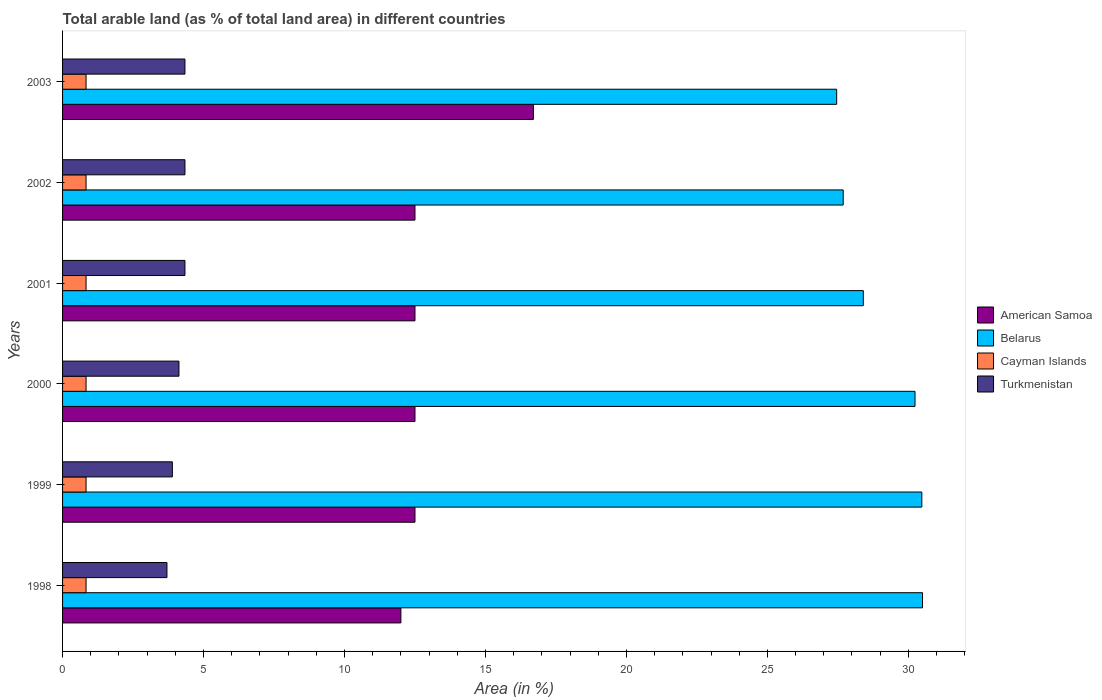How many different coloured bars are there?
Offer a very short reply. 4. How many groups of bars are there?
Provide a succinct answer. 6. Are the number of bars per tick equal to the number of legend labels?
Your answer should be very brief. Yes. How many bars are there on the 5th tick from the top?
Offer a very short reply. 4. How many bars are there on the 1st tick from the bottom?
Ensure brevity in your answer.  4. In how many cases, is the number of bars for a given year not equal to the number of legend labels?
Make the answer very short. 0. What is the percentage of arable land in Cayman Islands in 2003?
Offer a terse response. 0.83. Across all years, what is the maximum percentage of arable land in Cayman Islands?
Provide a succinct answer. 0.83. Across all years, what is the minimum percentage of arable land in Cayman Islands?
Give a very brief answer. 0.83. In which year was the percentage of arable land in Belarus maximum?
Offer a terse response. 1998. In which year was the percentage of arable land in Cayman Islands minimum?
Provide a succinct answer. 1998. What is the total percentage of arable land in Turkmenistan in the graph?
Provide a short and direct response. 24.75. What is the difference between the percentage of arable land in Turkmenistan in 1998 and the percentage of arable land in American Samoa in 2001?
Your answer should be very brief. -8.8. What is the average percentage of arable land in American Samoa per year?
Provide a succinct answer. 13.12. In the year 2001, what is the difference between the percentage of arable land in Turkmenistan and percentage of arable land in Cayman Islands?
Your response must be concise. 3.51. What is the ratio of the percentage of arable land in Cayman Islands in 1998 to that in 1999?
Provide a short and direct response. 1. What is the difference between the highest and the lowest percentage of arable land in Cayman Islands?
Give a very brief answer. 0. In how many years, is the percentage of arable land in Turkmenistan greater than the average percentage of arable land in Turkmenistan taken over all years?
Your response must be concise. 4. Is the sum of the percentage of arable land in Cayman Islands in 2000 and 2001 greater than the maximum percentage of arable land in American Samoa across all years?
Your response must be concise. No. What does the 4th bar from the top in 2003 represents?
Your response must be concise. American Samoa. What does the 1st bar from the bottom in 1998 represents?
Your answer should be compact. American Samoa. Is it the case that in every year, the sum of the percentage of arable land in American Samoa and percentage of arable land in Cayman Islands is greater than the percentage of arable land in Belarus?
Give a very brief answer. No. How many bars are there?
Offer a very short reply. 24. Are all the bars in the graph horizontal?
Provide a short and direct response. Yes. How many years are there in the graph?
Offer a very short reply. 6. Are the values on the major ticks of X-axis written in scientific E-notation?
Offer a terse response. No. Does the graph contain any zero values?
Your response must be concise. No. Where does the legend appear in the graph?
Make the answer very short. Center right. How many legend labels are there?
Give a very brief answer. 4. What is the title of the graph?
Your answer should be compact. Total arable land (as % of total land area) in different countries. What is the label or title of the X-axis?
Your answer should be compact. Area (in %). What is the label or title of the Y-axis?
Provide a succinct answer. Years. What is the Area (in %) in Belarus in 1998?
Keep it short and to the point. 30.5. What is the Area (in %) in Cayman Islands in 1998?
Your answer should be very brief. 0.83. What is the Area (in %) in Turkmenistan in 1998?
Your answer should be very brief. 3.7. What is the Area (in %) in Belarus in 1999?
Your answer should be very brief. 30.48. What is the Area (in %) in Cayman Islands in 1999?
Offer a terse response. 0.83. What is the Area (in %) of Turkmenistan in 1999?
Give a very brief answer. 3.89. What is the Area (in %) of Belarus in 2000?
Give a very brief answer. 30.24. What is the Area (in %) in Cayman Islands in 2000?
Make the answer very short. 0.83. What is the Area (in %) in Turkmenistan in 2000?
Provide a succinct answer. 4.13. What is the Area (in %) in American Samoa in 2001?
Make the answer very short. 12.5. What is the Area (in %) of Belarus in 2001?
Make the answer very short. 28.4. What is the Area (in %) of Cayman Islands in 2001?
Make the answer very short. 0.83. What is the Area (in %) in Turkmenistan in 2001?
Make the answer very short. 4.34. What is the Area (in %) in American Samoa in 2002?
Offer a terse response. 12.5. What is the Area (in %) of Belarus in 2002?
Give a very brief answer. 27.69. What is the Area (in %) in Cayman Islands in 2002?
Ensure brevity in your answer.  0.83. What is the Area (in %) of Turkmenistan in 2002?
Give a very brief answer. 4.34. What is the Area (in %) in Belarus in 2003?
Provide a short and direct response. 27.46. What is the Area (in %) in Cayman Islands in 2003?
Your response must be concise. 0.83. What is the Area (in %) in Turkmenistan in 2003?
Your answer should be very brief. 4.34. Across all years, what is the maximum Area (in %) of American Samoa?
Your response must be concise. 16.7. Across all years, what is the maximum Area (in %) of Belarus?
Provide a succinct answer. 30.5. Across all years, what is the maximum Area (in %) in Cayman Islands?
Your answer should be compact. 0.83. Across all years, what is the maximum Area (in %) in Turkmenistan?
Make the answer very short. 4.34. Across all years, what is the minimum Area (in %) in Belarus?
Your response must be concise. 27.46. Across all years, what is the minimum Area (in %) of Cayman Islands?
Give a very brief answer. 0.83. Across all years, what is the minimum Area (in %) of Turkmenistan?
Offer a very short reply. 3.7. What is the total Area (in %) in American Samoa in the graph?
Ensure brevity in your answer.  78.7. What is the total Area (in %) in Belarus in the graph?
Offer a very short reply. 174.76. What is the total Area (in %) of Turkmenistan in the graph?
Your response must be concise. 24.75. What is the difference between the Area (in %) in American Samoa in 1998 and that in 1999?
Give a very brief answer. -0.5. What is the difference between the Area (in %) of Belarus in 1998 and that in 1999?
Ensure brevity in your answer.  0.02. What is the difference between the Area (in %) in Turkmenistan in 1998 and that in 1999?
Provide a succinct answer. -0.19. What is the difference between the Area (in %) of American Samoa in 1998 and that in 2000?
Provide a short and direct response. -0.5. What is the difference between the Area (in %) in Belarus in 1998 and that in 2000?
Give a very brief answer. 0.27. What is the difference between the Area (in %) of Turkmenistan in 1998 and that in 2000?
Provide a succinct answer. -0.43. What is the difference between the Area (in %) of American Samoa in 1998 and that in 2001?
Ensure brevity in your answer.  -0.5. What is the difference between the Area (in %) in Belarus in 1998 and that in 2001?
Your answer should be compact. 2.1. What is the difference between the Area (in %) of Cayman Islands in 1998 and that in 2001?
Make the answer very short. 0. What is the difference between the Area (in %) in Turkmenistan in 1998 and that in 2001?
Provide a succinct answer. -0.64. What is the difference between the Area (in %) of American Samoa in 1998 and that in 2002?
Offer a very short reply. -0.5. What is the difference between the Area (in %) of Belarus in 1998 and that in 2002?
Your answer should be compact. 2.81. What is the difference between the Area (in %) of Turkmenistan in 1998 and that in 2002?
Provide a succinct answer. -0.64. What is the difference between the Area (in %) of American Samoa in 1998 and that in 2003?
Your response must be concise. -4.7. What is the difference between the Area (in %) in Belarus in 1998 and that in 2003?
Your response must be concise. 3.05. What is the difference between the Area (in %) of Cayman Islands in 1998 and that in 2003?
Your answer should be compact. 0. What is the difference between the Area (in %) of Turkmenistan in 1998 and that in 2003?
Give a very brief answer. -0.64. What is the difference between the Area (in %) of American Samoa in 1999 and that in 2000?
Your answer should be compact. 0. What is the difference between the Area (in %) in Belarus in 1999 and that in 2000?
Give a very brief answer. 0.24. What is the difference between the Area (in %) in Cayman Islands in 1999 and that in 2000?
Offer a very short reply. 0. What is the difference between the Area (in %) of Turkmenistan in 1999 and that in 2000?
Make the answer very short. -0.23. What is the difference between the Area (in %) of American Samoa in 1999 and that in 2001?
Offer a terse response. 0. What is the difference between the Area (in %) in Belarus in 1999 and that in 2001?
Your answer should be compact. 2.08. What is the difference between the Area (in %) in Cayman Islands in 1999 and that in 2001?
Provide a succinct answer. 0. What is the difference between the Area (in %) in Turkmenistan in 1999 and that in 2001?
Offer a terse response. -0.45. What is the difference between the Area (in %) in American Samoa in 1999 and that in 2002?
Your answer should be very brief. 0. What is the difference between the Area (in %) of Belarus in 1999 and that in 2002?
Keep it short and to the point. 2.79. What is the difference between the Area (in %) in Cayman Islands in 1999 and that in 2002?
Ensure brevity in your answer.  0. What is the difference between the Area (in %) of Turkmenistan in 1999 and that in 2002?
Your answer should be compact. -0.45. What is the difference between the Area (in %) of American Samoa in 1999 and that in 2003?
Give a very brief answer. -4.2. What is the difference between the Area (in %) of Belarus in 1999 and that in 2003?
Ensure brevity in your answer.  3.02. What is the difference between the Area (in %) of Turkmenistan in 1999 and that in 2003?
Keep it short and to the point. -0.45. What is the difference between the Area (in %) in Belarus in 2000 and that in 2001?
Your answer should be compact. 1.83. What is the difference between the Area (in %) of Cayman Islands in 2000 and that in 2001?
Keep it short and to the point. 0. What is the difference between the Area (in %) in Turkmenistan in 2000 and that in 2001?
Give a very brief answer. -0.21. What is the difference between the Area (in %) in Belarus in 2000 and that in 2002?
Provide a short and direct response. 2.55. What is the difference between the Area (in %) of Turkmenistan in 2000 and that in 2002?
Provide a short and direct response. -0.21. What is the difference between the Area (in %) of American Samoa in 2000 and that in 2003?
Ensure brevity in your answer.  -4.2. What is the difference between the Area (in %) in Belarus in 2000 and that in 2003?
Your answer should be very brief. 2.78. What is the difference between the Area (in %) of Turkmenistan in 2000 and that in 2003?
Give a very brief answer. -0.21. What is the difference between the Area (in %) in Belarus in 2001 and that in 2002?
Your answer should be very brief. 0.71. What is the difference between the Area (in %) of Cayman Islands in 2001 and that in 2002?
Your answer should be compact. 0. What is the difference between the Area (in %) in Turkmenistan in 2001 and that in 2002?
Give a very brief answer. 0. What is the difference between the Area (in %) in American Samoa in 2001 and that in 2003?
Your response must be concise. -4.2. What is the difference between the Area (in %) in Belarus in 2001 and that in 2003?
Offer a very short reply. 0.95. What is the difference between the Area (in %) in Turkmenistan in 2001 and that in 2003?
Make the answer very short. 0. What is the difference between the Area (in %) in Belarus in 2002 and that in 2003?
Give a very brief answer. 0.23. What is the difference between the Area (in %) of American Samoa in 1998 and the Area (in %) of Belarus in 1999?
Your answer should be compact. -18.48. What is the difference between the Area (in %) in American Samoa in 1998 and the Area (in %) in Cayman Islands in 1999?
Your response must be concise. 11.17. What is the difference between the Area (in %) of American Samoa in 1998 and the Area (in %) of Turkmenistan in 1999?
Keep it short and to the point. 8.11. What is the difference between the Area (in %) of Belarus in 1998 and the Area (in %) of Cayman Islands in 1999?
Offer a very short reply. 29.67. What is the difference between the Area (in %) of Belarus in 1998 and the Area (in %) of Turkmenistan in 1999?
Offer a very short reply. 26.61. What is the difference between the Area (in %) in Cayman Islands in 1998 and the Area (in %) in Turkmenistan in 1999?
Your response must be concise. -3.06. What is the difference between the Area (in %) of American Samoa in 1998 and the Area (in %) of Belarus in 2000?
Your answer should be very brief. -18.24. What is the difference between the Area (in %) in American Samoa in 1998 and the Area (in %) in Cayman Islands in 2000?
Your answer should be very brief. 11.17. What is the difference between the Area (in %) of American Samoa in 1998 and the Area (in %) of Turkmenistan in 2000?
Make the answer very short. 7.87. What is the difference between the Area (in %) of Belarus in 1998 and the Area (in %) of Cayman Islands in 2000?
Make the answer very short. 29.67. What is the difference between the Area (in %) of Belarus in 1998 and the Area (in %) of Turkmenistan in 2000?
Provide a short and direct response. 26.37. What is the difference between the Area (in %) of Cayman Islands in 1998 and the Area (in %) of Turkmenistan in 2000?
Ensure brevity in your answer.  -3.29. What is the difference between the Area (in %) in American Samoa in 1998 and the Area (in %) in Belarus in 2001?
Ensure brevity in your answer.  -16.4. What is the difference between the Area (in %) in American Samoa in 1998 and the Area (in %) in Cayman Islands in 2001?
Give a very brief answer. 11.17. What is the difference between the Area (in %) in American Samoa in 1998 and the Area (in %) in Turkmenistan in 2001?
Keep it short and to the point. 7.66. What is the difference between the Area (in %) in Belarus in 1998 and the Area (in %) in Cayman Islands in 2001?
Offer a terse response. 29.67. What is the difference between the Area (in %) of Belarus in 1998 and the Area (in %) of Turkmenistan in 2001?
Make the answer very short. 26.16. What is the difference between the Area (in %) in Cayman Islands in 1998 and the Area (in %) in Turkmenistan in 2001?
Ensure brevity in your answer.  -3.51. What is the difference between the Area (in %) of American Samoa in 1998 and the Area (in %) of Belarus in 2002?
Offer a terse response. -15.69. What is the difference between the Area (in %) of American Samoa in 1998 and the Area (in %) of Cayman Islands in 2002?
Your answer should be very brief. 11.17. What is the difference between the Area (in %) of American Samoa in 1998 and the Area (in %) of Turkmenistan in 2002?
Ensure brevity in your answer.  7.66. What is the difference between the Area (in %) of Belarus in 1998 and the Area (in %) of Cayman Islands in 2002?
Your answer should be very brief. 29.67. What is the difference between the Area (in %) of Belarus in 1998 and the Area (in %) of Turkmenistan in 2002?
Keep it short and to the point. 26.16. What is the difference between the Area (in %) of Cayman Islands in 1998 and the Area (in %) of Turkmenistan in 2002?
Provide a succinct answer. -3.51. What is the difference between the Area (in %) of American Samoa in 1998 and the Area (in %) of Belarus in 2003?
Your answer should be very brief. -15.46. What is the difference between the Area (in %) of American Samoa in 1998 and the Area (in %) of Cayman Islands in 2003?
Give a very brief answer. 11.17. What is the difference between the Area (in %) of American Samoa in 1998 and the Area (in %) of Turkmenistan in 2003?
Ensure brevity in your answer.  7.66. What is the difference between the Area (in %) in Belarus in 1998 and the Area (in %) in Cayman Islands in 2003?
Offer a terse response. 29.67. What is the difference between the Area (in %) of Belarus in 1998 and the Area (in %) of Turkmenistan in 2003?
Offer a terse response. 26.16. What is the difference between the Area (in %) of Cayman Islands in 1998 and the Area (in %) of Turkmenistan in 2003?
Your answer should be very brief. -3.51. What is the difference between the Area (in %) of American Samoa in 1999 and the Area (in %) of Belarus in 2000?
Keep it short and to the point. -17.74. What is the difference between the Area (in %) in American Samoa in 1999 and the Area (in %) in Cayman Islands in 2000?
Make the answer very short. 11.67. What is the difference between the Area (in %) in American Samoa in 1999 and the Area (in %) in Turkmenistan in 2000?
Your answer should be compact. 8.37. What is the difference between the Area (in %) of Belarus in 1999 and the Area (in %) of Cayman Islands in 2000?
Your answer should be very brief. 29.64. What is the difference between the Area (in %) of Belarus in 1999 and the Area (in %) of Turkmenistan in 2000?
Your response must be concise. 26.35. What is the difference between the Area (in %) in Cayman Islands in 1999 and the Area (in %) in Turkmenistan in 2000?
Make the answer very short. -3.29. What is the difference between the Area (in %) in American Samoa in 1999 and the Area (in %) in Belarus in 2001?
Offer a terse response. -15.9. What is the difference between the Area (in %) of American Samoa in 1999 and the Area (in %) of Cayman Islands in 2001?
Offer a terse response. 11.67. What is the difference between the Area (in %) in American Samoa in 1999 and the Area (in %) in Turkmenistan in 2001?
Provide a succinct answer. 8.16. What is the difference between the Area (in %) of Belarus in 1999 and the Area (in %) of Cayman Islands in 2001?
Your response must be concise. 29.64. What is the difference between the Area (in %) in Belarus in 1999 and the Area (in %) in Turkmenistan in 2001?
Your answer should be compact. 26.14. What is the difference between the Area (in %) in Cayman Islands in 1999 and the Area (in %) in Turkmenistan in 2001?
Ensure brevity in your answer.  -3.51. What is the difference between the Area (in %) of American Samoa in 1999 and the Area (in %) of Belarus in 2002?
Offer a terse response. -15.19. What is the difference between the Area (in %) of American Samoa in 1999 and the Area (in %) of Cayman Islands in 2002?
Keep it short and to the point. 11.67. What is the difference between the Area (in %) of American Samoa in 1999 and the Area (in %) of Turkmenistan in 2002?
Keep it short and to the point. 8.16. What is the difference between the Area (in %) in Belarus in 1999 and the Area (in %) in Cayman Islands in 2002?
Your response must be concise. 29.64. What is the difference between the Area (in %) in Belarus in 1999 and the Area (in %) in Turkmenistan in 2002?
Give a very brief answer. 26.14. What is the difference between the Area (in %) of Cayman Islands in 1999 and the Area (in %) of Turkmenistan in 2002?
Give a very brief answer. -3.51. What is the difference between the Area (in %) in American Samoa in 1999 and the Area (in %) in Belarus in 2003?
Offer a terse response. -14.96. What is the difference between the Area (in %) of American Samoa in 1999 and the Area (in %) of Cayman Islands in 2003?
Keep it short and to the point. 11.67. What is the difference between the Area (in %) in American Samoa in 1999 and the Area (in %) in Turkmenistan in 2003?
Your answer should be very brief. 8.16. What is the difference between the Area (in %) of Belarus in 1999 and the Area (in %) of Cayman Islands in 2003?
Ensure brevity in your answer.  29.64. What is the difference between the Area (in %) of Belarus in 1999 and the Area (in %) of Turkmenistan in 2003?
Keep it short and to the point. 26.14. What is the difference between the Area (in %) of Cayman Islands in 1999 and the Area (in %) of Turkmenistan in 2003?
Provide a short and direct response. -3.51. What is the difference between the Area (in %) in American Samoa in 2000 and the Area (in %) in Belarus in 2001?
Offer a terse response. -15.9. What is the difference between the Area (in %) in American Samoa in 2000 and the Area (in %) in Cayman Islands in 2001?
Ensure brevity in your answer.  11.67. What is the difference between the Area (in %) of American Samoa in 2000 and the Area (in %) of Turkmenistan in 2001?
Provide a succinct answer. 8.16. What is the difference between the Area (in %) of Belarus in 2000 and the Area (in %) of Cayman Islands in 2001?
Offer a terse response. 29.4. What is the difference between the Area (in %) in Belarus in 2000 and the Area (in %) in Turkmenistan in 2001?
Your answer should be compact. 25.89. What is the difference between the Area (in %) in Cayman Islands in 2000 and the Area (in %) in Turkmenistan in 2001?
Keep it short and to the point. -3.51. What is the difference between the Area (in %) in American Samoa in 2000 and the Area (in %) in Belarus in 2002?
Provide a succinct answer. -15.19. What is the difference between the Area (in %) of American Samoa in 2000 and the Area (in %) of Cayman Islands in 2002?
Offer a terse response. 11.67. What is the difference between the Area (in %) in American Samoa in 2000 and the Area (in %) in Turkmenistan in 2002?
Keep it short and to the point. 8.16. What is the difference between the Area (in %) of Belarus in 2000 and the Area (in %) of Cayman Islands in 2002?
Make the answer very short. 29.4. What is the difference between the Area (in %) in Belarus in 2000 and the Area (in %) in Turkmenistan in 2002?
Your answer should be very brief. 25.89. What is the difference between the Area (in %) of Cayman Islands in 2000 and the Area (in %) of Turkmenistan in 2002?
Your answer should be very brief. -3.51. What is the difference between the Area (in %) in American Samoa in 2000 and the Area (in %) in Belarus in 2003?
Make the answer very short. -14.96. What is the difference between the Area (in %) of American Samoa in 2000 and the Area (in %) of Cayman Islands in 2003?
Your answer should be compact. 11.67. What is the difference between the Area (in %) of American Samoa in 2000 and the Area (in %) of Turkmenistan in 2003?
Provide a short and direct response. 8.16. What is the difference between the Area (in %) in Belarus in 2000 and the Area (in %) in Cayman Islands in 2003?
Offer a very short reply. 29.4. What is the difference between the Area (in %) of Belarus in 2000 and the Area (in %) of Turkmenistan in 2003?
Your answer should be very brief. 25.89. What is the difference between the Area (in %) of Cayman Islands in 2000 and the Area (in %) of Turkmenistan in 2003?
Your response must be concise. -3.51. What is the difference between the Area (in %) in American Samoa in 2001 and the Area (in %) in Belarus in 2002?
Make the answer very short. -15.19. What is the difference between the Area (in %) in American Samoa in 2001 and the Area (in %) in Cayman Islands in 2002?
Offer a very short reply. 11.67. What is the difference between the Area (in %) in American Samoa in 2001 and the Area (in %) in Turkmenistan in 2002?
Offer a terse response. 8.16. What is the difference between the Area (in %) of Belarus in 2001 and the Area (in %) of Cayman Islands in 2002?
Give a very brief answer. 27.57. What is the difference between the Area (in %) of Belarus in 2001 and the Area (in %) of Turkmenistan in 2002?
Give a very brief answer. 24.06. What is the difference between the Area (in %) in Cayman Islands in 2001 and the Area (in %) in Turkmenistan in 2002?
Your answer should be compact. -3.51. What is the difference between the Area (in %) in American Samoa in 2001 and the Area (in %) in Belarus in 2003?
Make the answer very short. -14.96. What is the difference between the Area (in %) of American Samoa in 2001 and the Area (in %) of Cayman Islands in 2003?
Offer a terse response. 11.67. What is the difference between the Area (in %) of American Samoa in 2001 and the Area (in %) of Turkmenistan in 2003?
Your answer should be compact. 8.16. What is the difference between the Area (in %) in Belarus in 2001 and the Area (in %) in Cayman Islands in 2003?
Your answer should be compact. 27.57. What is the difference between the Area (in %) in Belarus in 2001 and the Area (in %) in Turkmenistan in 2003?
Your answer should be compact. 24.06. What is the difference between the Area (in %) in Cayman Islands in 2001 and the Area (in %) in Turkmenistan in 2003?
Keep it short and to the point. -3.51. What is the difference between the Area (in %) of American Samoa in 2002 and the Area (in %) of Belarus in 2003?
Offer a very short reply. -14.96. What is the difference between the Area (in %) in American Samoa in 2002 and the Area (in %) in Cayman Islands in 2003?
Provide a short and direct response. 11.67. What is the difference between the Area (in %) of American Samoa in 2002 and the Area (in %) of Turkmenistan in 2003?
Make the answer very short. 8.16. What is the difference between the Area (in %) in Belarus in 2002 and the Area (in %) in Cayman Islands in 2003?
Make the answer very short. 26.85. What is the difference between the Area (in %) in Belarus in 2002 and the Area (in %) in Turkmenistan in 2003?
Offer a terse response. 23.35. What is the difference between the Area (in %) in Cayman Islands in 2002 and the Area (in %) in Turkmenistan in 2003?
Provide a short and direct response. -3.51. What is the average Area (in %) in American Samoa per year?
Keep it short and to the point. 13.12. What is the average Area (in %) of Belarus per year?
Offer a very short reply. 29.13. What is the average Area (in %) of Cayman Islands per year?
Give a very brief answer. 0.83. What is the average Area (in %) in Turkmenistan per year?
Keep it short and to the point. 4.12. In the year 1998, what is the difference between the Area (in %) in American Samoa and Area (in %) in Belarus?
Ensure brevity in your answer.  -18.5. In the year 1998, what is the difference between the Area (in %) of American Samoa and Area (in %) of Cayman Islands?
Ensure brevity in your answer.  11.17. In the year 1998, what is the difference between the Area (in %) of American Samoa and Area (in %) of Turkmenistan?
Offer a terse response. 8.3. In the year 1998, what is the difference between the Area (in %) in Belarus and Area (in %) in Cayman Islands?
Make the answer very short. 29.67. In the year 1998, what is the difference between the Area (in %) in Belarus and Area (in %) in Turkmenistan?
Your answer should be very brief. 26.8. In the year 1998, what is the difference between the Area (in %) of Cayman Islands and Area (in %) of Turkmenistan?
Ensure brevity in your answer.  -2.87. In the year 1999, what is the difference between the Area (in %) of American Samoa and Area (in %) of Belarus?
Your response must be concise. -17.98. In the year 1999, what is the difference between the Area (in %) of American Samoa and Area (in %) of Cayman Islands?
Your response must be concise. 11.67. In the year 1999, what is the difference between the Area (in %) in American Samoa and Area (in %) in Turkmenistan?
Your response must be concise. 8.61. In the year 1999, what is the difference between the Area (in %) of Belarus and Area (in %) of Cayman Islands?
Give a very brief answer. 29.64. In the year 1999, what is the difference between the Area (in %) of Belarus and Area (in %) of Turkmenistan?
Give a very brief answer. 26.58. In the year 1999, what is the difference between the Area (in %) of Cayman Islands and Area (in %) of Turkmenistan?
Give a very brief answer. -3.06. In the year 2000, what is the difference between the Area (in %) of American Samoa and Area (in %) of Belarus?
Ensure brevity in your answer.  -17.74. In the year 2000, what is the difference between the Area (in %) in American Samoa and Area (in %) in Cayman Islands?
Provide a succinct answer. 11.67. In the year 2000, what is the difference between the Area (in %) of American Samoa and Area (in %) of Turkmenistan?
Give a very brief answer. 8.37. In the year 2000, what is the difference between the Area (in %) of Belarus and Area (in %) of Cayman Islands?
Keep it short and to the point. 29.4. In the year 2000, what is the difference between the Area (in %) in Belarus and Area (in %) in Turkmenistan?
Provide a succinct answer. 26.11. In the year 2000, what is the difference between the Area (in %) in Cayman Islands and Area (in %) in Turkmenistan?
Keep it short and to the point. -3.29. In the year 2001, what is the difference between the Area (in %) of American Samoa and Area (in %) of Belarus?
Provide a short and direct response. -15.9. In the year 2001, what is the difference between the Area (in %) in American Samoa and Area (in %) in Cayman Islands?
Ensure brevity in your answer.  11.67. In the year 2001, what is the difference between the Area (in %) in American Samoa and Area (in %) in Turkmenistan?
Ensure brevity in your answer.  8.16. In the year 2001, what is the difference between the Area (in %) of Belarus and Area (in %) of Cayman Islands?
Your answer should be compact. 27.57. In the year 2001, what is the difference between the Area (in %) in Belarus and Area (in %) in Turkmenistan?
Keep it short and to the point. 24.06. In the year 2001, what is the difference between the Area (in %) in Cayman Islands and Area (in %) in Turkmenistan?
Your answer should be very brief. -3.51. In the year 2002, what is the difference between the Area (in %) of American Samoa and Area (in %) of Belarus?
Your answer should be compact. -15.19. In the year 2002, what is the difference between the Area (in %) in American Samoa and Area (in %) in Cayman Islands?
Make the answer very short. 11.67. In the year 2002, what is the difference between the Area (in %) in American Samoa and Area (in %) in Turkmenistan?
Provide a short and direct response. 8.16. In the year 2002, what is the difference between the Area (in %) of Belarus and Area (in %) of Cayman Islands?
Provide a succinct answer. 26.85. In the year 2002, what is the difference between the Area (in %) in Belarus and Area (in %) in Turkmenistan?
Your answer should be compact. 23.35. In the year 2002, what is the difference between the Area (in %) of Cayman Islands and Area (in %) of Turkmenistan?
Make the answer very short. -3.51. In the year 2003, what is the difference between the Area (in %) in American Samoa and Area (in %) in Belarus?
Offer a very short reply. -10.76. In the year 2003, what is the difference between the Area (in %) of American Samoa and Area (in %) of Cayman Islands?
Provide a succinct answer. 15.87. In the year 2003, what is the difference between the Area (in %) in American Samoa and Area (in %) in Turkmenistan?
Your response must be concise. 12.36. In the year 2003, what is the difference between the Area (in %) in Belarus and Area (in %) in Cayman Islands?
Ensure brevity in your answer.  26.62. In the year 2003, what is the difference between the Area (in %) in Belarus and Area (in %) in Turkmenistan?
Offer a very short reply. 23.12. In the year 2003, what is the difference between the Area (in %) of Cayman Islands and Area (in %) of Turkmenistan?
Provide a succinct answer. -3.51. What is the ratio of the Area (in %) in Belarus in 1998 to that in 1999?
Provide a short and direct response. 1. What is the ratio of the Area (in %) of Cayman Islands in 1998 to that in 1999?
Your answer should be very brief. 1. What is the ratio of the Area (in %) of Turkmenistan in 1998 to that in 1999?
Ensure brevity in your answer.  0.95. What is the ratio of the Area (in %) of American Samoa in 1998 to that in 2000?
Provide a short and direct response. 0.96. What is the ratio of the Area (in %) of Belarus in 1998 to that in 2000?
Your response must be concise. 1.01. What is the ratio of the Area (in %) in Cayman Islands in 1998 to that in 2000?
Give a very brief answer. 1. What is the ratio of the Area (in %) of Turkmenistan in 1998 to that in 2000?
Make the answer very short. 0.9. What is the ratio of the Area (in %) of American Samoa in 1998 to that in 2001?
Keep it short and to the point. 0.96. What is the ratio of the Area (in %) in Belarus in 1998 to that in 2001?
Your answer should be very brief. 1.07. What is the ratio of the Area (in %) in Turkmenistan in 1998 to that in 2001?
Your answer should be very brief. 0.85. What is the ratio of the Area (in %) in American Samoa in 1998 to that in 2002?
Your answer should be very brief. 0.96. What is the ratio of the Area (in %) of Belarus in 1998 to that in 2002?
Keep it short and to the point. 1.1. What is the ratio of the Area (in %) in Turkmenistan in 1998 to that in 2002?
Your answer should be compact. 0.85. What is the ratio of the Area (in %) in American Samoa in 1998 to that in 2003?
Offer a terse response. 0.72. What is the ratio of the Area (in %) of Belarus in 1998 to that in 2003?
Offer a terse response. 1.11. What is the ratio of the Area (in %) in Cayman Islands in 1998 to that in 2003?
Your answer should be compact. 1. What is the ratio of the Area (in %) in Turkmenistan in 1998 to that in 2003?
Your answer should be compact. 0.85. What is the ratio of the Area (in %) in Turkmenistan in 1999 to that in 2000?
Your answer should be compact. 0.94. What is the ratio of the Area (in %) of American Samoa in 1999 to that in 2001?
Your answer should be very brief. 1. What is the ratio of the Area (in %) of Belarus in 1999 to that in 2001?
Offer a very short reply. 1.07. What is the ratio of the Area (in %) of Cayman Islands in 1999 to that in 2001?
Your answer should be compact. 1. What is the ratio of the Area (in %) of Turkmenistan in 1999 to that in 2001?
Give a very brief answer. 0.9. What is the ratio of the Area (in %) of Belarus in 1999 to that in 2002?
Give a very brief answer. 1.1. What is the ratio of the Area (in %) in Turkmenistan in 1999 to that in 2002?
Offer a very short reply. 0.9. What is the ratio of the Area (in %) in American Samoa in 1999 to that in 2003?
Offer a very short reply. 0.75. What is the ratio of the Area (in %) in Belarus in 1999 to that in 2003?
Your response must be concise. 1.11. What is the ratio of the Area (in %) in Turkmenistan in 1999 to that in 2003?
Your answer should be very brief. 0.9. What is the ratio of the Area (in %) of American Samoa in 2000 to that in 2001?
Your answer should be very brief. 1. What is the ratio of the Area (in %) of Belarus in 2000 to that in 2001?
Your answer should be compact. 1.06. What is the ratio of the Area (in %) of Turkmenistan in 2000 to that in 2001?
Your response must be concise. 0.95. What is the ratio of the Area (in %) of Belarus in 2000 to that in 2002?
Provide a short and direct response. 1.09. What is the ratio of the Area (in %) in Turkmenistan in 2000 to that in 2002?
Keep it short and to the point. 0.95. What is the ratio of the Area (in %) in American Samoa in 2000 to that in 2003?
Make the answer very short. 0.75. What is the ratio of the Area (in %) of Belarus in 2000 to that in 2003?
Make the answer very short. 1.1. What is the ratio of the Area (in %) in Cayman Islands in 2000 to that in 2003?
Provide a short and direct response. 1. What is the ratio of the Area (in %) of Turkmenistan in 2000 to that in 2003?
Ensure brevity in your answer.  0.95. What is the ratio of the Area (in %) in American Samoa in 2001 to that in 2002?
Your response must be concise. 1. What is the ratio of the Area (in %) in Belarus in 2001 to that in 2002?
Keep it short and to the point. 1.03. What is the ratio of the Area (in %) in Cayman Islands in 2001 to that in 2002?
Make the answer very short. 1. What is the ratio of the Area (in %) of American Samoa in 2001 to that in 2003?
Your answer should be compact. 0.75. What is the ratio of the Area (in %) in Belarus in 2001 to that in 2003?
Offer a terse response. 1.03. What is the ratio of the Area (in %) in Cayman Islands in 2001 to that in 2003?
Your answer should be compact. 1. What is the ratio of the Area (in %) of American Samoa in 2002 to that in 2003?
Your answer should be compact. 0.75. What is the ratio of the Area (in %) of Belarus in 2002 to that in 2003?
Give a very brief answer. 1.01. What is the ratio of the Area (in %) of Turkmenistan in 2002 to that in 2003?
Provide a succinct answer. 1. What is the difference between the highest and the second highest Area (in %) of American Samoa?
Your response must be concise. 4.2. What is the difference between the highest and the second highest Area (in %) of Belarus?
Make the answer very short. 0.02. What is the difference between the highest and the second highest Area (in %) of Turkmenistan?
Your answer should be compact. 0. What is the difference between the highest and the lowest Area (in %) in American Samoa?
Keep it short and to the point. 4.7. What is the difference between the highest and the lowest Area (in %) in Belarus?
Your answer should be very brief. 3.05. What is the difference between the highest and the lowest Area (in %) in Turkmenistan?
Keep it short and to the point. 0.64. 